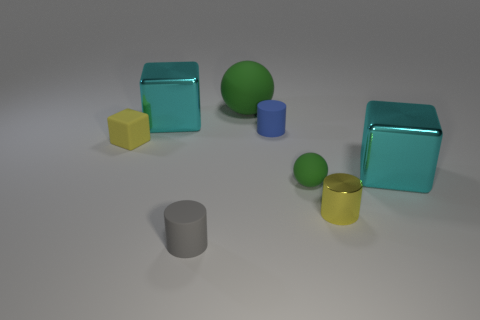Is the shape of the cyan object that is on the right side of the big rubber thing the same as  the gray matte thing?
Offer a very short reply. No. What is the material of the cyan object that is left of the tiny green object?
Offer a very short reply. Metal. What number of other big objects have the same shape as the yellow rubber object?
Ensure brevity in your answer.  2. There is a cyan block on the right side of the cylinder behind the tiny cube; what is its material?
Offer a very short reply. Metal. The matte thing that is the same color as the large rubber ball is what shape?
Offer a very short reply. Sphere. Are there any big gray cylinders made of the same material as the blue cylinder?
Ensure brevity in your answer.  No. What is the shape of the yellow metal thing?
Your answer should be very brief. Cylinder. What number of green things are there?
Provide a short and direct response. 2. What is the color of the cube on the right side of the big cyan object that is behind the yellow matte object?
Offer a terse response. Cyan. The ball that is the same size as the gray thing is what color?
Provide a succinct answer. Green. 